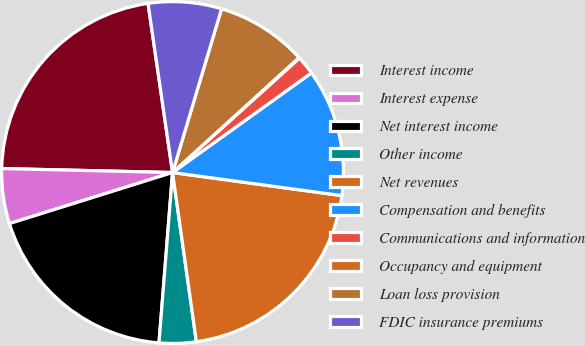Convert chart. <chart><loc_0><loc_0><loc_500><loc_500><pie_chart><fcel>Interest income<fcel>Interest expense<fcel>Net interest income<fcel>Other income<fcel>Net revenues<fcel>Compensation and benefits<fcel>Communications and information<fcel>Occupancy and equipment<fcel>Loan loss provision<fcel>FDIC insurance premiums<nl><fcel>22.34%<fcel>5.2%<fcel>18.91%<fcel>3.49%<fcel>20.62%<fcel>12.06%<fcel>1.78%<fcel>0.06%<fcel>8.63%<fcel>6.92%<nl></chart> 